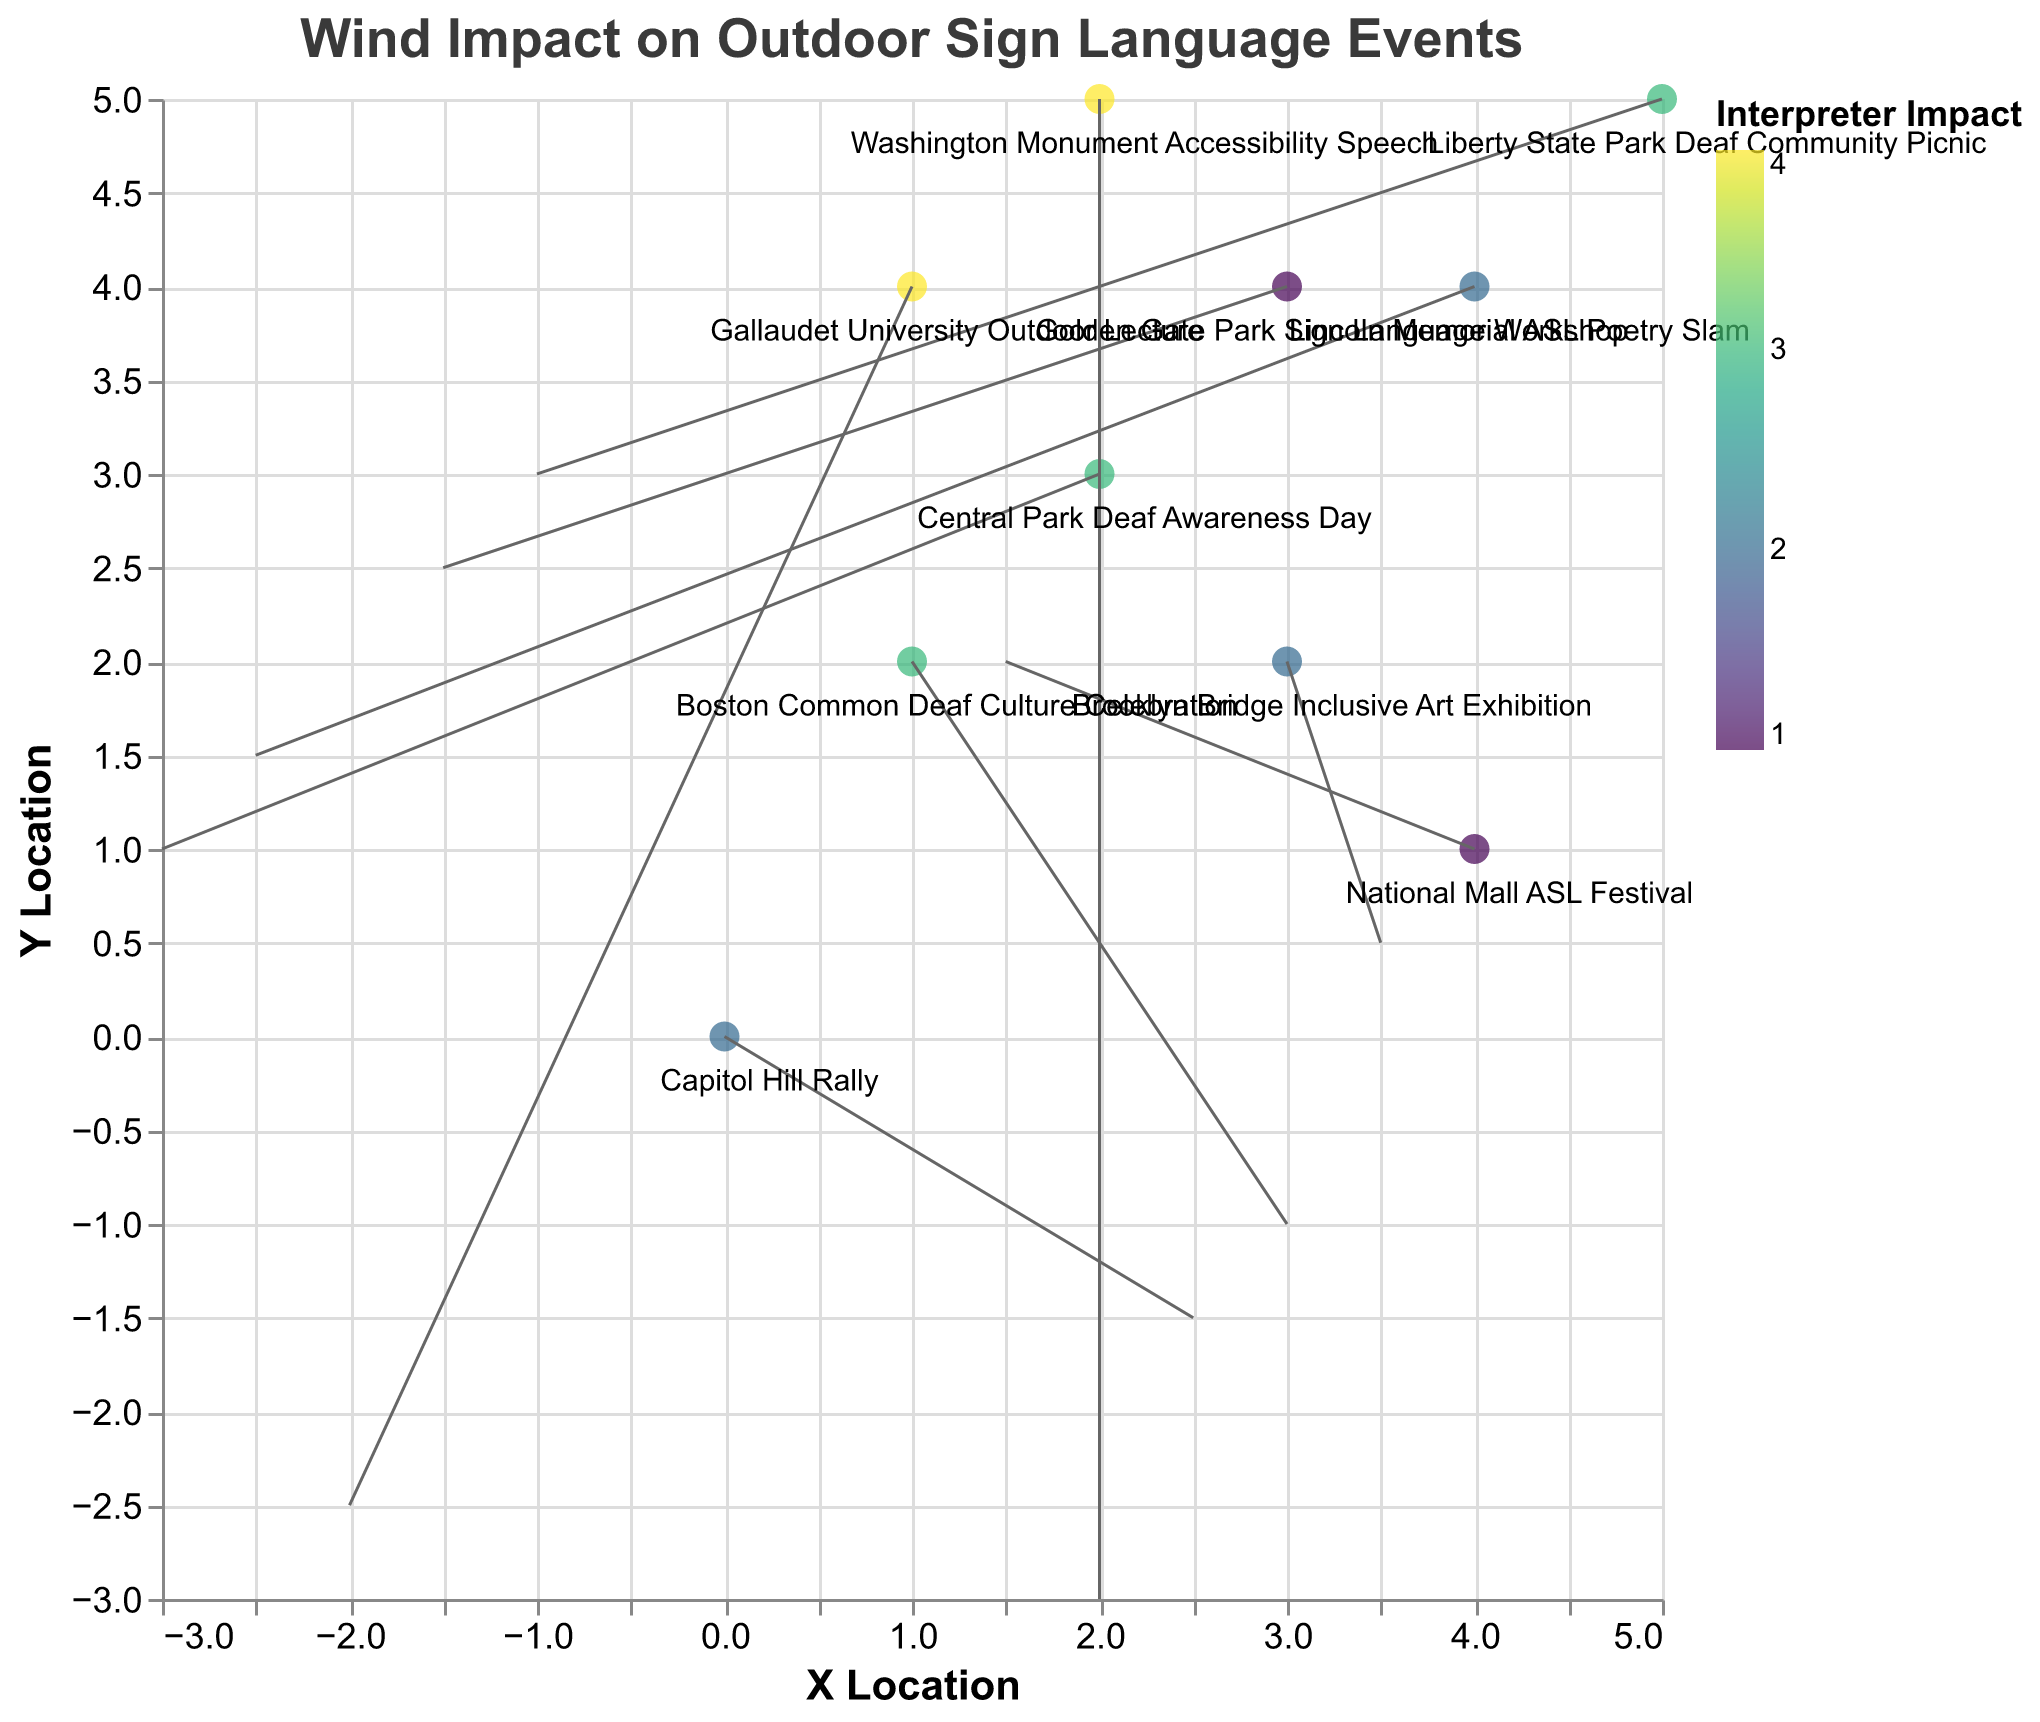What is the title of the figure? The title of the figure is located at the top and it reads "Wind Impact on Outdoor Sign Language Events".
Answer: Wind Impact on Outdoor Sign Language Events Which event has the highest interpreter impact? Look for the data point with the highest value in the color scale for "Interpreter Impact". The darkest color corresponds to Gallaudet University Outdoor Lecture.
Answer: Gallaudet University Outdoor Lecture Which event has a wind vector pointing southwest? Identify the event with negative values for both `u` and `v` wind components. Gallaudet University Outdoor Lecture has a vector with u = -2.0 and v = -2.5, indicating southwest direction.
Answer: Gallaudet University Outdoor Lecture What is the x and y location of the Washington Monument Accessibility Speech event? Find the "Washington Monument Accessibility Speech" label and observe its coordinates along the axes. It is at x = 2 and y = 5.
Answer: x = 2, y = 5 Which event has the strongest wind speed? Calculate the wind speeds using the formula sqrt(u^2 + v^2) for each event, and find the maximum. Brooklyn Bridge Inclusive Art Exhibition has u = 3.5 and v = 0.5, so sqrt(3.5^2 + 0.5^2) = sqrt(12.25 + 0.25) = sqrt(12.5).
Answer: Brooklyn Bridge Inclusive Art Exhibition Compare the interpreter impact of the Capitol Hill Rally and Central Park Deaf Awareness Day. The interpreter impact for Capitol Hill Rally is 2, while for Central Park Deaf Awareness Day it is 3. Comparing these, the Central Park Deaf Awareness Day has a higher impact value.
Answer: Central Park Deaf Awareness Day has a higher interpreter impact Which event's wind direction is mostly vertical? Look for the event where the horizontal component u is small compared to the vertical component v. Liberty State Park Deaf Community Picnic has u = -1.0 and v = 3.0, making the wind direction primarily vertical (northward).
Answer: Liberty State Park Deaf Community Picnic What is the average interpreter impact across all events shown? Sum the interpreter impacts and divide by the number of events: (2 + 3 + 1 + 4 + 2 + 3 + 4 + 2 + 3 + 1) / 10 = 2.5.
Answer: 2.5 